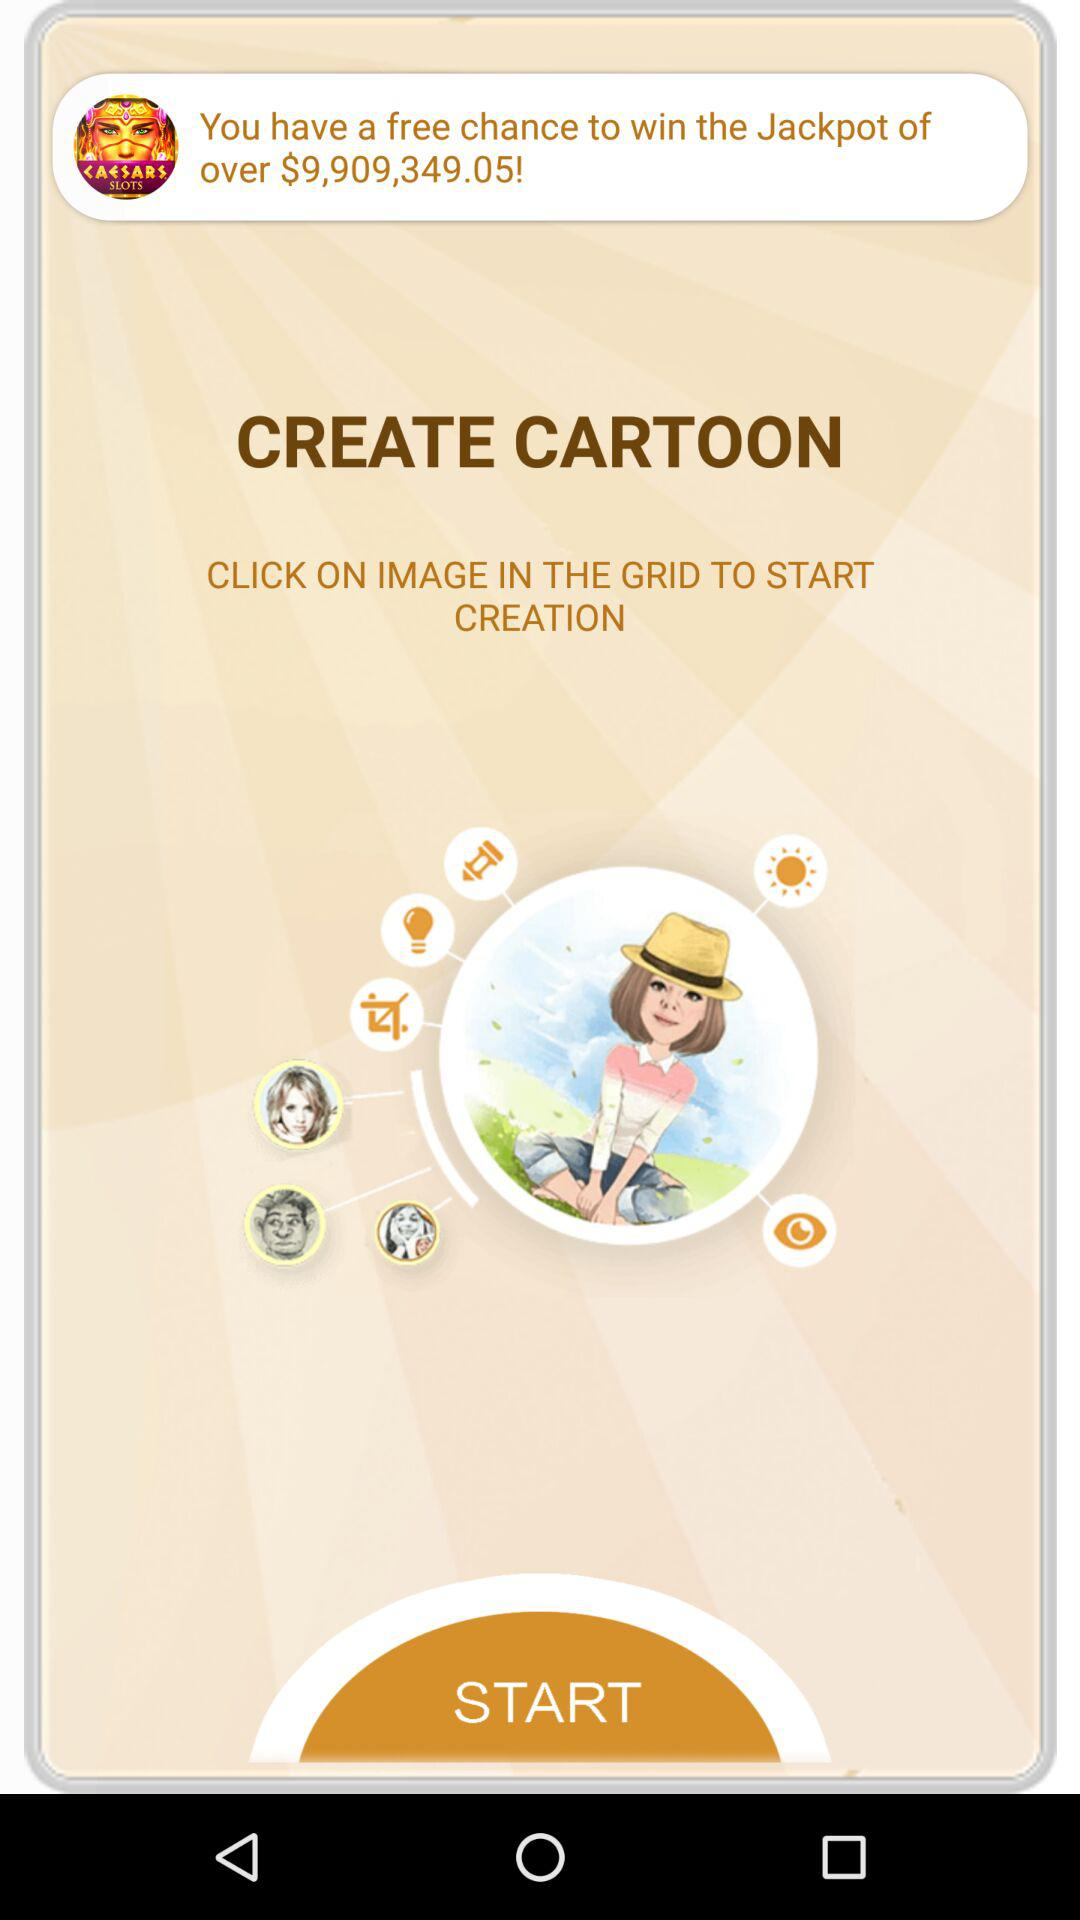The free chance to win the jackpot over what amount is? The amount is over $9,909,349.05. 